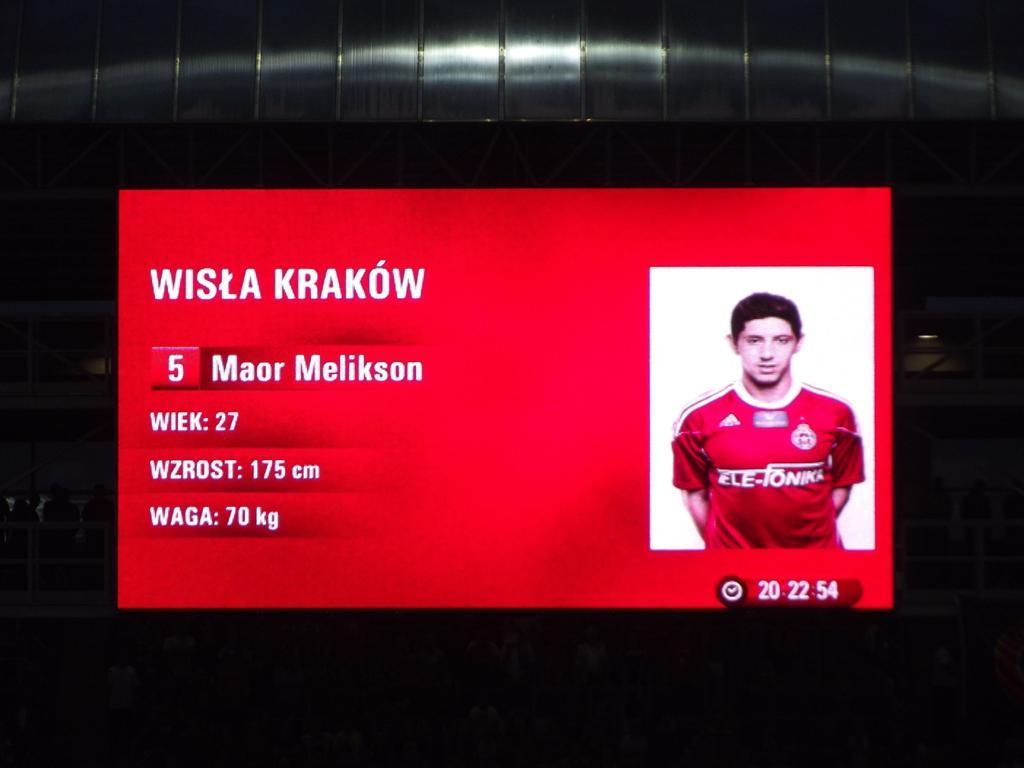What is the main subject of the image of the television screen? The main subject of the television screen is a player. What can be seen on the television screen besides the player? The television screen shows details of the player. What type of theory can be seen being discussed by the frogs in the image? There are no frogs present in the image, and therefore no theory can be seen being discussed. 